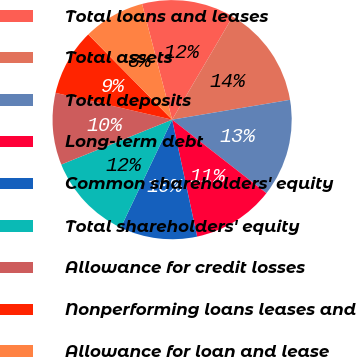Convert chart. <chart><loc_0><loc_0><loc_500><loc_500><pie_chart><fcel>Total loans and leases<fcel>Total assets<fcel>Total deposits<fcel>Long-term debt<fcel>Common shareholders' equity<fcel>Total shareholders' equity<fcel>Allowance for credit losses<fcel>Nonperforming loans leases and<fcel>Allowance for loan and lease<nl><fcel>12.5%<fcel>13.89%<fcel>13.19%<fcel>11.11%<fcel>10.42%<fcel>11.81%<fcel>9.72%<fcel>9.03%<fcel>8.33%<nl></chart> 